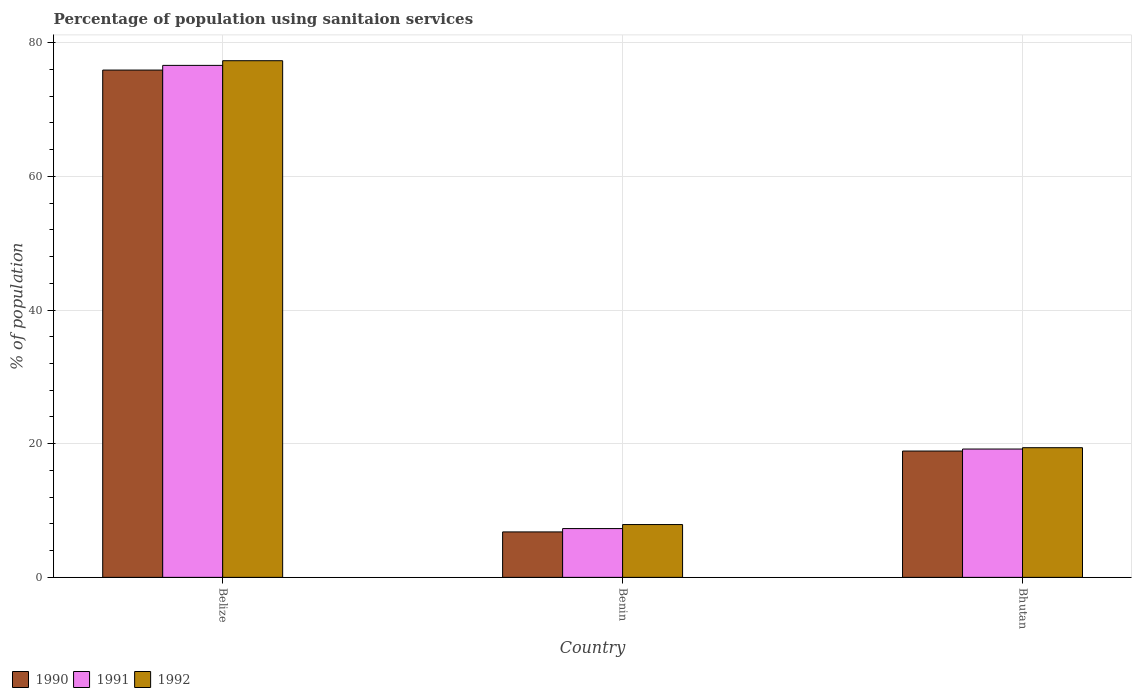How many different coloured bars are there?
Your answer should be very brief. 3. How many groups of bars are there?
Offer a terse response. 3. How many bars are there on the 2nd tick from the left?
Keep it short and to the point. 3. What is the label of the 2nd group of bars from the left?
Your answer should be compact. Benin. In how many cases, is the number of bars for a given country not equal to the number of legend labels?
Provide a short and direct response. 0. What is the percentage of population using sanitaion services in 1991 in Belize?
Make the answer very short. 76.6. Across all countries, what is the maximum percentage of population using sanitaion services in 1992?
Keep it short and to the point. 77.3. Across all countries, what is the minimum percentage of population using sanitaion services in 1992?
Ensure brevity in your answer.  7.9. In which country was the percentage of population using sanitaion services in 1991 maximum?
Make the answer very short. Belize. In which country was the percentage of population using sanitaion services in 1991 minimum?
Your answer should be very brief. Benin. What is the total percentage of population using sanitaion services in 1992 in the graph?
Offer a terse response. 104.6. What is the difference between the percentage of population using sanitaion services in 1990 in Belize and that in Bhutan?
Give a very brief answer. 57. What is the difference between the percentage of population using sanitaion services in 1990 in Bhutan and the percentage of population using sanitaion services in 1991 in Belize?
Ensure brevity in your answer.  -57.7. What is the average percentage of population using sanitaion services in 1990 per country?
Provide a succinct answer. 33.87. What is the difference between the percentage of population using sanitaion services of/in 1992 and percentage of population using sanitaion services of/in 1991 in Bhutan?
Ensure brevity in your answer.  0.2. In how many countries, is the percentage of population using sanitaion services in 1992 greater than 52 %?
Ensure brevity in your answer.  1. What is the ratio of the percentage of population using sanitaion services in 1992 in Benin to that in Bhutan?
Give a very brief answer. 0.41. What is the difference between the highest and the second highest percentage of population using sanitaion services in 1990?
Your response must be concise. -57. What is the difference between the highest and the lowest percentage of population using sanitaion services in 1991?
Your answer should be compact. 69.3. In how many countries, is the percentage of population using sanitaion services in 1992 greater than the average percentage of population using sanitaion services in 1992 taken over all countries?
Keep it short and to the point. 1. Is the sum of the percentage of population using sanitaion services in 1992 in Benin and Bhutan greater than the maximum percentage of population using sanitaion services in 1990 across all countries?
Provide a succinct answer. No. How many bars are there?
Ensure brevity in your answer.  9. Are all the bars in the graph horizontal?
Your response must be concise. No. How many countries are there in the graph?
Your answer should be compact. 3. Does the graph contain any zero values?
Give a very brief answer. No. How many legend labels are there?
Your answer should be compact. 3. What is the title of the graph?
Provide a short and direct response. Percentage of population using sanitaion services. Does "1993" appear as one of the legend labels in the graph?
Provide a succinct answer. No. What is the label or title of the Y-axis?
Your answer should be compact. % of population. What is the % of population of 1990 in Belize?
Keep it short and to the point. 75.9. What is the % of population in 1991 in Belize?
Give a very brief answer. 76.6. What is the % of population of 1992 in Belize?
Provide a short and direct response. 77.3. What is the % of population of 1991 in Benin?
Provide a succinct answer. 7.3. Across all countries, what is the maximum % of population in 1990?
Your response must be concise. 75.9. Across all countries, what is the maximum % of population of 1991?
Your answer should be very brief. 76.6. Across all countries, what is the maximum % of population of 1992?
Your answer should be compact. 77.3. Across all countries, what is the minimum % of population in 1990?
Ensure brevity in your answer.  6.8. Across all countries, what is the minimum % of population of 1991?
Your answer should be compact. 7.3. What is the total % of population in 1990 in the graph?
Ensure brevity in your answer.  101.6. What is the total % of population of 1991 in the graph?
Ensure brevity in your answer.  103.1. What is the total % of population of 1992 in the graph?
Provide a succinct answer. 104.6. What is the difference between the % of population of 1990 in Belize and that in Benin?
Keep it short and to the point. 69.1. What is the difference between the % of population in 1991 in Belize and that in Benin?
Give a very brief answer. 69.3. What is the difference between the % of population of 1992 in Belize and that in Benin?
Make the answer very short. 69.4. What is the difference between the % of population in 1990 in Belize and that in Bhutan?
Keep it short and to the point. 57. What is the difference between the % of population of 1991 in Belize and that in Bhutan?
Your response must be concise. 57.4. What is the difference between the % of population in 1992 in Belize and that in Bhutan?
Offer a terse response. 57.9. What is the difference between the % of population of 1990 in Benin and that in Bhutan?
Your answer should be very brief. -12.1. What is the difference between the % of population of 1992 in Benin and that in Bhutan?
Offer a terse response. -11.5. What is the difference between the % of population of 1990 in Belize and the % of population of 1991 in Benin?
Offer a terse response. 68.6. What is the difference between the % of population in 1990 in Belize and the % of population in 1992 in Benin?
Give a very brief answer. 68. What is the difference between the % of population of 1991 in Belize and the % of population of 1992 in Benin?
Provide a succinct answer. 68.7. What is the difference between the % of population in 1990 in Belize and the % of population in 1991 in Bhutan?
Provide a succinct answer. 56.7. What is the difference between the % of population of 1990 in Belize and the % of population of 1992 in Bhutan?
Provide a short and direct response. 56.5. What is the difference between the % of population in 1991 in Belize and the % of population in 1992 in Bhutan?
Keep it short and to the point. 57.2. What is the difference between the % of population of 1990 in Benin and the % of population of 1991 in Bhutan?
Your answer should be very brief. -12.4. What is the average % of population in 1990 per country?
Your answer should be compact. 33.87. What is the average % of population in 1991 per country?
Your answer should be very brief. 34.37. What is the average % of population of 1992 per country?
Offer a terse response. 34.87. What is the difference between the % of population in 1990 and % of population in 1992 in Belize?
Provide a short and direct response. -1.4. What is the difference between the % of population in 1990 and % of population in 1991 in Bhutan?
Keep it short and to the point. -0.3. What is the difference between the % of population of 1990 and % of population of 1992 in Bhutan?
Your answer should be compact. -0.5. What is the ratio of the % of population in 1990 in Belize to that in Benin?
Your response must be concise. 11.16. What is the ratio of the % of population in 1991 in Belize to that in Benin?
Your answer should be compact. 10.49. What is the ratio of the % of population of 1992 in Belize to that in Benin?
Provide a succinct answer. 9.78. What is the ratio of the % of population of 1990 in Belize to that in Bhutan?
Give a very brief answer. 4.02. What is the ratio of the % of population of 1991 in Belize to that in Bhutan?
Provide a succinct answer. 3.99. What is the ratio of the % of population of 1992 in Belize to that in Bhutan?
Your answer should be compact. 3.98. What is the ratio of the % of population in 1990 in Benin to that in Bhutan?
Offer a very short reply. 0.36. What is the ratio of the % of population of 1991 in Benin to that in Bhutan?
Provide a short and direct response. 0.38. What is the ratio of the % of population of 1992 in Benin to that in Bhutan?
Keep it short and to the point. 0.41. What is the difference between the highest and the second highest % of population of 1990?
Your response must be concise. 57. What is the difference between the highest and the second highest % of population in 1991?
Provide a succinct answer. 57.4. What is the difference between the highest and the second highest % of population in 1992?
Your answer should be compact. 57.9. What is the difference between the highest and the lowest % of population in 1990?
Your response must be concise. 69.1. What is the difference between the highest and the lowest % of population in 1991?
Your answer should be very brief. 69.3. What is the difference between the highest and the lowest % of population of 1992?
Your answer should be compact. 69.4. 